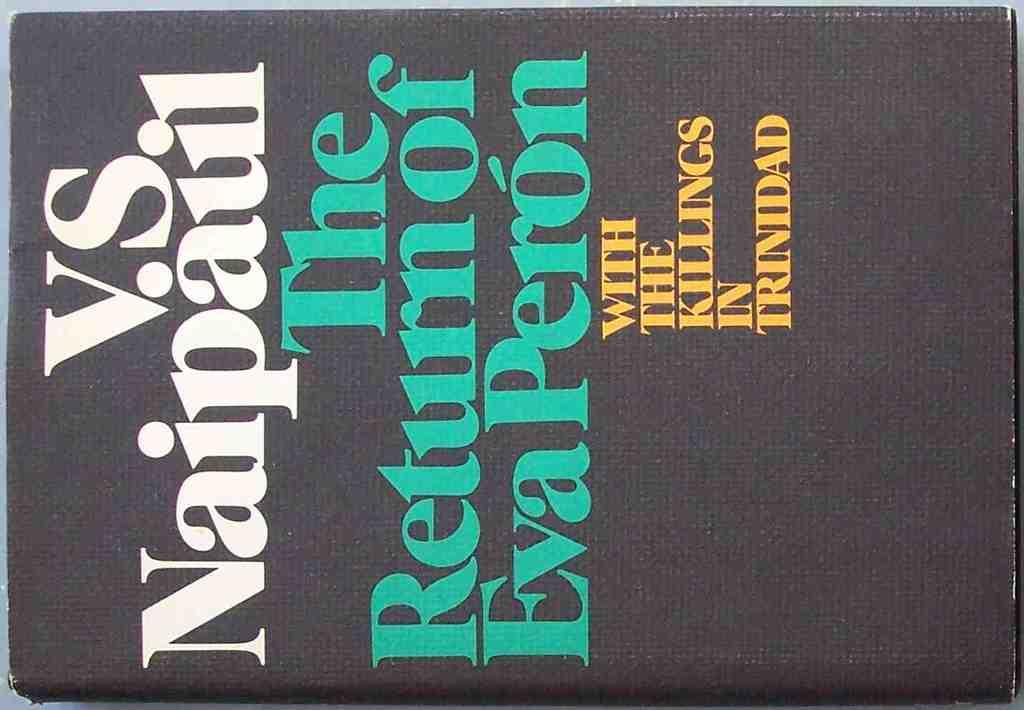Provide a one-sentence caption for the provided image. Book saying V.S. Naipaul The Return of Eva Peron with the Killings of Trinidad. 